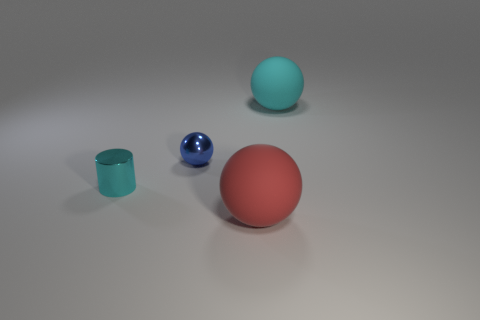What is the cyan object that is behind the cylinder made of?
Provide a short and direct response. Rubber. There is a matte thing behind the cyan object that is on the left side of the cyan thing that is behind the small ball; what color is it?
Your response must be concise. Cyan. There is another metal thing that is the same size as the blue metal thing; what color is it?
Give a very brief answer. Cyan. How many metallic objects are tiny blue balls or tiny red cylinders?
Provide a short and direct response. 1. The tiny object that is the same material as the blue sphere is what color?
Keep it short and to the point. Cyan. The large thing in front of the big matte thing that is behind the blue object is made of what material?
Provide a short and direct response. Rubber. What number of objects are big balls right of the large red thing or large spheres in front of the blue ball?
Your answer should be very brief. 2. There is a cyan thing on the left side of the large matte ball behind the big object in front of the cyan matte ball; what size is it?
Make the answer very short. Small. Are there an equal number of metallic cylinders that are on the left side of the tiny cylinder and tiny metallic cubes?
Give a very brief answer. Yes. Is there anything else that has the same shape as the big red thing?
Offer a very short reply. Yes. 